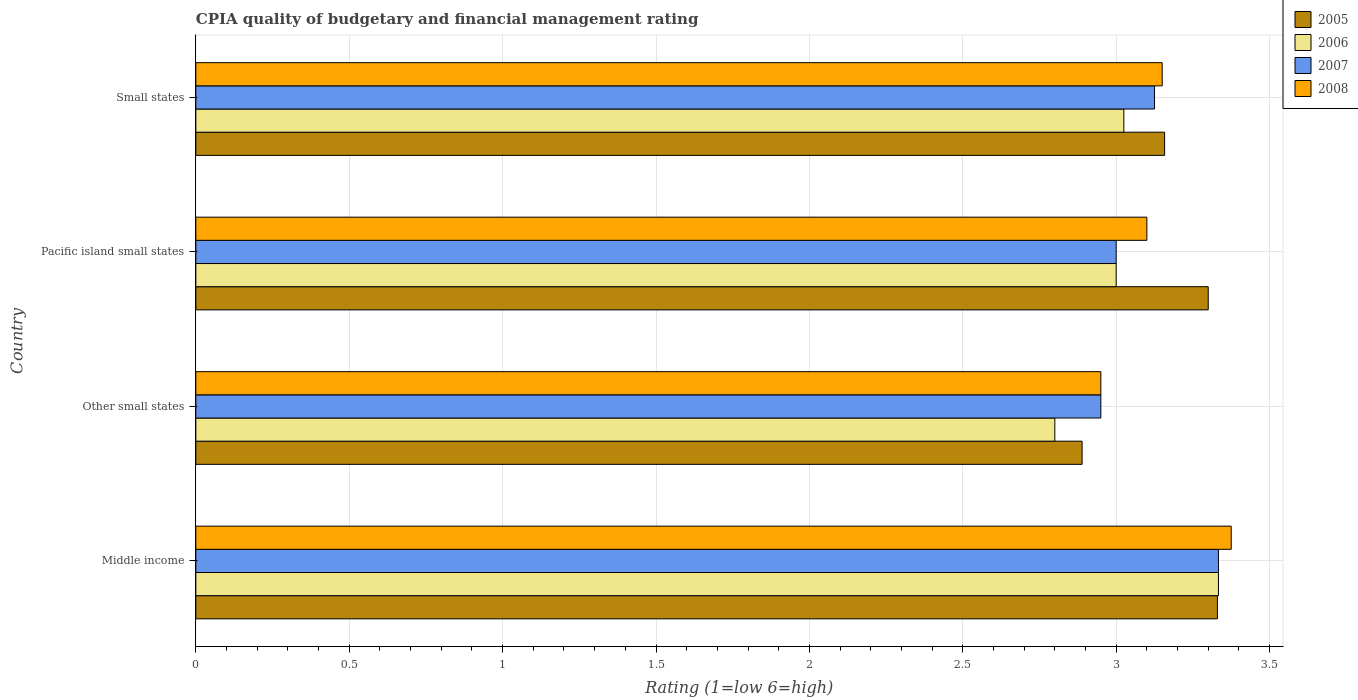How many different coloured bars are there?
Your response must be concise. 4. Are the number of bars on each tick of the Y-axis equal?
Make the answer very short. Yes. How many bars are there on the 4th tick from the bottom?
Offer a very short reply. 4. What is the label of the 3rd group of bars from the top?
Your answer should be compact. Other small states. In how many cases, is the number of bars for a given country not equal to the number of legend labels?
Ensure brevity in your answer.  0. What is the CPIA rating in 2007 in Small states?
Your response must be concise. 3.12. Across all countries, what is the maximum CPIA rating in 2005?
Keep it short and to the point. 3.33. Across all countries, what is the minimum CPIA rating in 2005?
Your answer should be compact. 2.89. In which country was the CPIA rating in 2008 minimum?
Your answer should be compact. Other small states. What is the total CPIA rating in 2008 in the graph?
Provide a succinct answer. 12.58. What is the difference between the CPIA rating in 2008 in Other small states and that in Small states?
Your response must be concise. -0.2. What is the difference between the CPIA rating in 2005 in Other small states and the CPIA rating in 2006 in Small states?
Keep it short and to the point. -0.14. What is the average CPIA rating in 2008 per country?
Ensure brevity in your answer.  3.14. What is the difference between the CPIA rating in 2007 and CPIA rating in 2005 in Other small states?
Provide a short and direct response. 0.06. What is the ratio of the CPIA rating in 2007 in Other small states to that in Pacific island small states?
Offer a terse response. 0.98. Is the CPIA rating in 2008 in Middle income less than that in Other small states?
Keep it short and to the point. No. Is the difference between the CPIA rating in 2007 in Middle income and Pacific island small states greater than the difference between the CPIA rating in 2005 in Middle income and Pacific island small states?
Offer a terse response. Yes. What is the difference between the highest and the second highest CPIA rating in 2006?
Offer a terse response. 0.31. What is the difference between the highest and the lowest CPIA rating in 2005?
Give a very brief answer. 0.44. Is the sum of the CPIA rating in 2006 in Middle income and Small states greater than the maximum CPIA rating in 2005 across all countries?
Ensure brevity in your answer.  Yes. What does the 4th bar from the top in Small states represents?
Offer a very short reply. 2005. Is it the case that in every country, the sum of the CPIA rating in 2008 and CPIA rating in 2006 is greater than the CPIA rating in 2007?
Give a very brief answer. Yes. How many bars are there?
Your response must be concise. 16. Are all the bars in the graph horizontal?
Give a very brief answer. Yes. How many countries are there in the graph?
Provide a short and direct response. 4. Where does the legend appear in the graph?
Your answer should be compact. Top right. What is the title of the graph?
Offer a very short reply. CPIA quality of budgetary and financial management rating. Does "1968" appear as one of the legend labels in the graph?
Offer a terse response. No. What is the label or title of the X-axis?
Make the answer very short. Rating (1=low 6=high). What is the label or title of the Y-axis?
Provide a succinct answer. Country. What is the Rating (1=low 6=high) of 2005 in Middle income?
Offer a very short reply. 3.33. What is the Rating (1=low 6=high) in 2006 in Middle income?
Your response must be concise. 3.33. What is the Rating (1=low 6=high) in 2007 in Middle income?
Make the answer very short. 3.33. What is the Rating (1=low 6=high) of 2008 in Middle income?
Make the answer very short. 3.38. What is the Rating (1=low 6=high) of 2005 in Other small states?
Offer a terse response. 2.89. What is the Rating (1=low 6=high) in 2007 in Other small states?
Your answer should be compact. 2.95. What is the Rating (1=low 6=high) in 2008 in Other small states?
Offer a very short reply. 2.95. What is the Rating (1=low 6=high) of 2005 in Pacific island small states?
Your response must be concise. 3.3. What is the Rating (1=low 6=high) in 2008 in Pacific island small states?
Offer a terse response. 3.1. What is the Rating (1=low 6=high) of 2005 in Small states?
Ensure brevity in your answer.  3.16. What is the Rating (1=low 6=high) in 2006 in Small states?
Your answer should be very brief. 3.02. What is the Rating (1=low 6=high) in 2007 in Small states?
Provide a succinct answer. 3.12. What is the Rating (1=low 6=high) in 2008 in Small states?
Your response must be concise. 3.15. Across all countries, what is the maximum Rating (1=low 6=high) in 2005?
Provide a short and direct response. 3.33. Across all countries, what is the maximum Rating (1=low 6=high) of 2006?
Offer a terse response. 3.33. Across all countries, what is the maximum Rating (1=low 6=high) of 2007?
Make the answer very short. 3.33. Across all countries, what is the maximum Rating (1=low 6=high) in 2008?
Your answer should be very brief. 3.38. Across all countries, what is the minimum Rating (1=low 6=high) of 2005?
Give a very brief answer. 2.89. Across all countries, what is the minimum Rating (1=low 6=high) of 2006?
Your answer should be very brief. 2.8. Across all countries, what is the minimum Rating (1=low 6=high) of 2007?
Make the answer very short. 2.95. Across all countries, what is the minimum Rating (1=low 6=high) of 2008?
Your response must be concise. 2.95. What is the total Rating (1=low 6=high) in 2005 in the graph?
Your answer should be very brief. 12.68. What is the total Rating (1=low 6=high) of 2006 in the graph?
Provide a short and direct response. 12.16. What is the total Rating (1=low 6=high) in 2007 in the graph?
Keep it short and to the point. 12.41. What is the total Rating (1=low 6=high) of 2008 in the graph?
Your answer should be very brief. 12.57. What is the difference between the Rating (1=low 6=high) in 2005 in Middle income and that in Other small states?
Provide a short and direct response. 0.44. What is the difference between the Rating (1=low 6=high) of 2006 in Middle income and that in Other small states?
Your response must be concise. 0.53. What is the difference between the Rating (1=low 6=high) of 2007 in Middle income and that in Other small states?
Give a very brief answer. 0.38. What is the difference between the Rating (1=low 6=high) of 2008 in Middle income and that in Other small states?
Offer a very short reply. 0.42. What is the difference between the Rating (1=low 6=high) of 2006 in Middle income and that in Pacific island small states?
Your answer should be very brief. 0.33. What is the difference between the Rating (1=low 6=high) of 2007 in Middle income and that in Pacific island small states?
Offer a terse response. 0.33. What is the difference between the Rating (1=low 6=high) of 2008 in Middle income and that in Pacific island small states?
Provide a succinct answer. 0.28. What is the difference between the Rating (1=low 6=high) of 2005 in Middle income and that in Small states?
Make the answer very short. 0.17. What is the difference between the Rating (1=low 6=high) in 2006 in Middle income and that in Small states?
Keep it short and to the point. 0.31. What is the difference between the Rating (1=low 6=high) in 2007 in Middle income and that in Small states?
Make the answer very short. 0.21. What is the difference between the Rating (1=low 6=high) of 2008 in Middle income and that in Small states?
Your response must be concise. 0.23. What is the difference between the Rating (1=low 6=high) in 2005 in Other small states and that in Pacific island small states?
Provide a succinct answer. -0.41. What is the difference between the Rating (1=low 6=high) of 2007 in Other small states and that in Pacific island small states?
Make the answer very short. -0.05. What is the difference between the Rating (1=low 6=high) of 2005 in Other small states and that in Small states?
Your answer should be compact. -0.27. What is the difference between the Rating (1=low 6=high) of 2006 in Other small states and that in Small states?
Ensure brevity in your answer.  -0.23. What is the difference between the Rating (1=low 6=high) in 2007 in Other small states and that in Small states?
Give a very brief answer. -0.17. What is the difference between the Rating (1=low 6=high) in 2008 in Other small states and that in Small states?
Provide a short and direct response. -0.2. What is the difference between the Rating (1=low 6=high) of 2005 in Pacific island small states and that in Small states?
Give a very brief answer. 0.14. What is the difference between the Rating (1=low 6=high) in 2006 in Pacific island small states and that in Small states?
Offer a very short reply. -0.03. What is the difference between the Rating (1=low 6=high) of 2007 in Pacific island small states and that in Small states?
Give a very brief answer. -0.12. What is the difference between the Rating (1=low 6=high) of 2005 in Middle income and the Rating (1=low 6=high) of 2006 in Other small states?
Provide a succinct answer. 0.53. What is the difference between the Rating (1=low 6=high) in 2005 in Middle income and the Rating (1=low 6=high) in 2007 in Other small states?
Give a very brief answer. 0.38. What is the difference between the Rating (1=low 6=high) in 2005 in Middle income and the Rating (1=low 6=high) in 2008 in Other small states?
Make the answer very short. 0.38. What is the difference between the Rating (1=low 6=high) of 2006 in Middle income and the Rating (1=low 6=high) of 2007 in Other small states?
Offer a very short reply. 0.38. What is the difference between the Rating (1=low 6=high) in 2006 in Middle income and the Rating (1=low 6=high) in 2008 in Other small states?
Your response must be concise. 0.38. What is the difference between the Rating (1=low 6=high) of 2007 in Middle income and the Rating (1=low 6=high) of 2008 in Other small states?
Provide a succinct answer. 0.38. What is the difference between the Rating (1=low 6=high) in 2005 in Middle income and the Rating (1=low 6=high) in 2006 in Pacific island small states?
Your response must be concise. 0.33. What is the difference between the Rating (1=low 6=high) of 2005 in Middle income and the Rating (1=low 6=high) of 2007 in Pacific island small states?
Offer a terse response. 0.33. What is the difference between the Rating (1=low 6=high) of 2005 in Middle income and the Rating (1=low 6=high) of 2008 in Pacific island small states?
Make the answer very short. 0.23. What is the difference between the Rating (1=low 6=high) in 2006 in Middle income and the Rating (1=low 6=high) in 2007 in Pacific island small states?
Keep it short and to the point. 0.33. What is the difference between the Rating (1=low 6=high) of 2006 in Middle income and the Rating (1=low 6=high) of 2008 in Pacific island small states?
Your response must be concise. 0.23. What is the difference between the Rating (1=low 6=high) in 2007 in Middle income and the Rating (1=low 6=high) in 2008 in Pacific island small states?
Make the answer very short. 0.23. What is the difference between the Rating (1=low 6=high) in 2005 in Middle income and the Rating (1=low 6=high) in 2006 in Small states?
Your answer should be very brief. 0.3. What is the difference between the Rating (1=low 6=high) of 2005 in Middle income and the Rating (1=low 6=high) of 2007 in Small states?
Give a very brief answer. 0.2. What is the difference between the Rating (1=low 6=high) in 2005 in Middle income and the Rating (1=low 6=high) in 2008 in Small states?
Offer a very short reply. 0.18. What is the difference between the Rating (1=low 6=high) of 2006 in Middle income and the Rating (1=low 6=high) of 2007 in Small states?
Give a very brief answer. 0.21. What is the difference between the Rating (1=low 6=high) in 2006 in Middle income and the Rating (1=low 6=high) in 2008 in Small states?
Your response must be concise. 0.18. What is the difference between the Rating (1=low 6=high) in 2007 in Middle income and the Rating (1=low 6=high) in 2008 in Small states?
Provide a short and direct response. 0.18. What is the difference between the Rating (1=low 6=high) of 2005 in Other small states and the Rating (1=low 6=high) of 2006 in Pacific island small states?
Provide a succinct answer. -0.11. What is the difference between the Rating (1=low 6=high) in 2005 in Other small states and the Rating (1=low 6=high) in 2007 in Pacific island small states?
Give a very brief answer. -0.11. What is the difference between the Rating (1=low 6=high) in 2005 in Other small states and the Rating (1=low 6=high) in 2008 in Pacific island small states?
Your answer should be compact. -0.21. What is the difference between the Rating (1=low 6=high) in 2006 in Other small states and the Rating (1=low 6=high) in 2007 in Pacific island small states?
Offer a very short reply. -0.2. What is the difference between the Rating (1=low 6=high) of 2007 in Other small states and the Rating (1=low 6=high) of 2008 in Pacific island small states?
Offer a terse response. -0.15. What is the difference between the Rating (1=low 6=high) in 2005 in Other small states and the Rating (1=low 6=high) in 2006 in Small states?
Ensure brevity in your answer.  -0.14. What is the difference between the Rating (1=low 6=high) in 2005 in Other small states and the Rating (1=low 6=high) in 2007 in Small states?
Your answer should be very brief. -0.24. What is the difference between the Rating (1=low 6=high) of 2005 in Other small states and the Rating (1=low 6=high) of 2008 in Small states?
Offer a terse response. -0.26. What is the difference between the Rating (1=low 6=high) of 2006 in Other small states and the Rating (1=low 6=high) of 2007 in Small states?
Offer a terse response. -0.33. What is the difference between the Rating (1=low 6=high) of 2006 in Other small states and the Rating (1=low 6=high) of 2008 in Small states?
Provide a short and direct response. -0.35. What is the difference between the Rating (1=low 6=high) in 2007 in Other small states and the Rating (1=low 6=high) in 2008 in Small states?
Your response must be concise. -0.2. What is the difference between the Rating (1=low 6=high) of 2005 in Pacific island small states and the Rating (1=low 6=high) of 2006 in Small states?
Offer a terse response. 0.28. What is the difference between the Rating (1=low 6=high) of 2005 in Pacific island small states and the Rating (1=low 6=high) of 2007 in Small states?
Provide a succinct answer. 0.17. What is the difference between the Rating (1=low 6=high) in 2005 in Pacific island small states and the Rating (1=low 6=high) in 2008 in Small states?
Your answer should be very brief. 0.15. What is the difference between the Rating (1=low 6=high) in 2006 in Pacific island small states and the Rating (1=low 6=high) in 2007 in Small states?
Offer a very short reply. -0.12. What is the difference between the Rating (1=low 6=high) of 2007 in Pacific island small states and the Rating (1=low 6=high) of 2008 in Small states?
Offer a terse response. -0.15. What is the average Rating (1=low 6=high) in 2005 per country?
Your answer should be compact. 3.17. What is the average Rating (1=low 6=high) in 2006 per country?
Ensure brevity in your answer.  3.04. What is the average Rating (1=low 6=high) in 2007 per country?
Your answer should be compact. 3.1. What is the average Rating (1=low 6=high) in 2008 per country?
Ensure brevity in your answer.  3.14. What is the difference between the Rating (1=low 6=high) in 2005 and Rating (1=low 6=high) in 2006 in Middle income?
Your answer should be compact. -0. What is the difference between the Rating (1=low 6=high) in 2005 and Rating (1=low 6=high) in 2007 in Middle income?
Your response must be concise. -0. What is the difference between the Rating (1=low 6=high) of 2005 and Rating (1=low 6=high) of 2008 in Middle income?
Offer a terse response. -0.04. What is the difference between the Rating (1=low 6=high) in 2006 and Rating (1=low 6=high) in 2008 in Middle income?
Offer a terse response. -0.04. What is the difference between the Rating (1=low 6=high) in 2007 and Rating (1=low 6=high) in 2008 in Middle income?
Give a very brief answer. -0.04. What is the difference between the Rating (1=low 6=high) in 2005 and Rating (1=low 6=high) in 2006 in Other small states?
Your response must be concise. 0.09. What is the difference between the Rating (1=low 6=high) of 2005 and Rating (1=low 6=high) of 2007 in Other small states?
Your response must be concise. -0.06. What is the difference between the Rating (1=low 6=high) in 2005 and Rating (1=low 6=high) in 2008 in Other small states?
Your answer should be compact. -0.06. What is the difference between the Rating (1=low 6=high) of 2006 and Rating (1=low 6=high) of 2008 in Other small states?
Your response must be concise. -0.15. What is the difference between the Rating (1=low 6=high) of 2005 and Rating (1=low 6=high) of 2006 in Pacific island small states?
Offer a terse response. 0.3. What is the difference between the Rating (1=low 6=high) in 2005 and Rating (1=low 6=high) in 2007 in Pacific island small states?
Make the answer very short. 0.3. What is the difference between the Rating (1=low 6=high) of 2005 and Rating (1=low 6=high) of 2008 in Pacific island small states?
Provide a short and direct response. 0.2. What is the difference between the Rating (1=low 6=high) in 2006 and Rating (1=low 6=high) in 2007 in Pacific island small states?
Your answer should be compact. 0. What is the difference between the Rating (1=low 6=high) of 2006 and Rating (1=low 6=high) of 2008 in Pacific island small states?
Make the answer very short. -0.1. What is the difference between the Rating (1=low 6=high) in 2007 and Rating (1=low 6=high) in 2008 in Pacific island small states?
Give a very brief answer. -0.1. What is the difference between the Rating (1=low 6=high) in 2005 and Rating (1=low 6=high) in 2006 in Small states?
Provide a succinct answer. 0.13. What is the difference between the Rating (1=low 6=high) of 2005 and Rating (1=low 6=high) of 2007 in Small states?
Your response must be concise. 0.03. What is the difference between the Rating (1=low 6=high) in 2005 and Rating (1=low 6=high) in 2008 in Small states?
Provide a short and direct response. 0.01. What is the difference between the Rating (1=low 6=high) in 2006 and Rating (1=low 6=high) in 2008 in Small states?
Your answer should be compact. -0.12. What is the difference between the Rating (1=low 6=high) in 2007 and Rating (1=low 6=high) in 2008 in Small states?
Your response must be concise. -0.03. What is the ratio of the Rating (1=low 6=high) in 2005 in Middle income to that in Other small states?
Ensure brevity in your answer.  1.15. What is the ratio of the Rating (1=low 6=high) in 2006 in Middle income to that in Other small states?
Offer a terse response. 1.19. What is the ratio of the Rating (1=low 6=high) in 2007 in Middle income to that in Other small states?
Keep it short and to the point. 1.13. What is the ratio of the Rating (1=low 6=high) in 2008 in Middle income to that in Other small states?
Offer a terse response. 1.14. What is the ratio of the Rating (1=low 6=high) of 2005 in Middle income to that in Pacific island small states?
Your answer should be very brief. 1.01. What is the ratio of the Rating (1=low 6=high) of 2006 in Middle income to that in Pacific island small states?
Give a very brief answer. 1.11. What is the ratio of the Rating (1=low 6=high) of 2007 in Middle income to that in Pacific island small states?
Offer a very short reply. 1.11. What is the ratio of the Rating (1=low 6=high) in 2008 in Middle income to that in Pacific island small states?
Provide a short and direct response. 1.09. What is the ratio of the Rating (1=low 6=high) in 2005 in Middle income to that in Small states?
Your response must be concise. 1.05. What is the ratio of the Rating (1=low 6=high) of 2006 in Middle income to that in Small states?
Your answer should be very brief. 1.1. What is the ratio of the Rating (1=low 6=high) of 2007 in Middle income to that in Small states?
Keep it short and to the point. 1.07. What is the ratio of the Rating (1=low 6=high) of 2008 in Middle income to that in Small states?
Offer a very short reply. 1.07. What is the ratio of the Rating (1=low 6=high) in 2005 in Other small states to that in Pacific island small states?
Offer a very short reply. 0.88. What is the ratio of the Rating (1=low 6=high) of 2007 in Other small states to that in Pacific island small states?
Your answer should be compact. 0.98. What is the ratio of the Rating (1=low 6=high) in 2008 in Other small states to that in Pacific island small states?
Offer a terse response. 0.95. What is the ratio of the Rating (1=low 6=high) in 2005 in Other small states to that in Small states?
Make the answer very short. 0.91. What is the ratio of the Rating (1=low 6=high) of 2006 in Other small states to that in Small states?
Ensure brevity in your answer.  0.93. What is the ratio of the Rating (1=low 6=high) in 2007 in Other small states to that in Small states?
Your answer should be very brief. 0.94. What is the ratio of the Rating (1=low 6=high) of 2008 in Other small states to that in Small states?
Make the answer very short. 0.94. What is the ratio of the Rating (1=low 6=high) in 2005 in Pacific island small states to that in Small states?
Provide a succinct answer. 1.04. What is the ratio of the Rating (1=low 6=high) in 2006 in Pacific island small states to that in Small states?
Offer a terse response. 0.99. What is the ratio of the Rating (1=low 6=high) in 2007 in Pacific island small states to that in Small states?
Offer a very short reply. 0.96. What is the ratio of the Rating (1=low 6=high) of 2008 in Pacific island small states to that in Small states?
Offer a terse response. 0.98. What is the difference between the highest and the second highest Rating (1=low 6=high) in 2005?
Provide a succinct answer. 0.03. What is the difference between the highest and the second highest Rating (1=low 6=high) in 2006?
Provide a short and direct response. 0.31. What is the difference between the highest and the second highest Rating (1=low 6=high) of 2007?
Provide a short and direct response. 0.21. What is the difference between the highest and the second highest Rating (1=low 6=high) of 2008?
Offer a very short reply. 0.23. What is the difference between the highest and the lowest Rating (1=low 6=high) in 2005?
Your answer should be very brief. 0.44. What is the difference between the highest and the lowest Rating (1=low 6=high) in 2006?
Your answer should be very brief. 0.53. What is the difference between the highest and the lowest Rating (1=low 6=high) in 2007?
Provide a short and direct response. 0.38. What is the difference between the highest and the lowest Rating (1=low 6=high) in 2008?
Give a very brief answer. 0.42. 